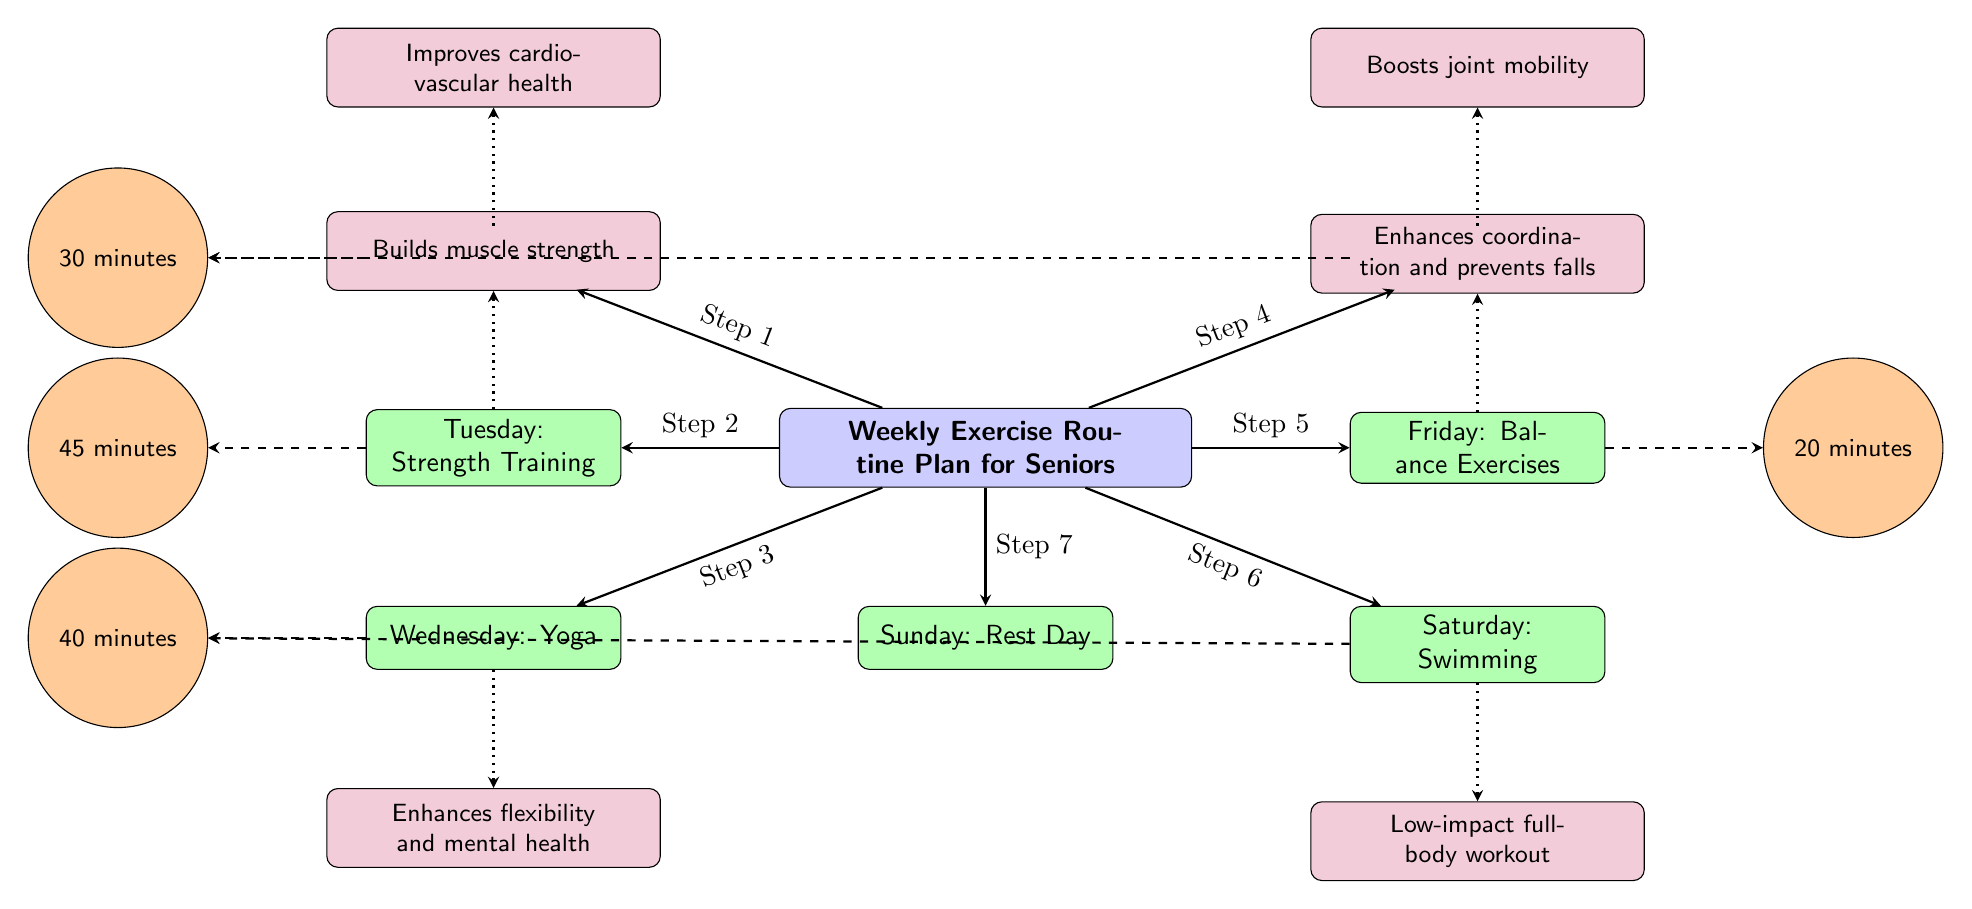What exercise is scheduled for Wednesday? The diagram shows that the exercise planned for Wednesday is "Yoga." This is directly represented in the "Wednesday" node.
Answer: Yoga How long should Tuesday's strength training last? According to the diagram, Tuesday's strength training is indicated to last for "45 minutes." This is found in the "duration" node connected to Tuesday.
Answer: 45 minutes What is the benefit of cycling on Thursday? The diagram states that the benefit of cycling on Thursday is "Boosts joint mobility." This information can be found in the respective "benefit" node connected to Thursday.
Answer: Boosts joint mobility Which exercise has the longest duration and what is that duration? The longest duration exercise is for “Strength Training” on Tuesday, which lasts "45 minutes." To confirm, one can compare the durations listed with each exercise and see that "45 minutes" is the highest.
Answer: 45 minutes What type of exercise is included for Saturday? The diagram specifies that the exercise planned for Saturday is "Swimming." This is visible in the "Saturday" node.
Answer: Swimming What is the health benefit associated with balance exercises? The diagram indicates that the health benefit of "Balance Exercises" on Friday is "Enhances coordination and prevents falls." This is connected explicitly in the benefit node for Friday.
Answer: Enhances coordination and prevents falls Which exercise corresponds to a 40-minute duration and on which day is it scheduled? The exercise scheduled for a 40-minute duration is "Yoga," which takes place on Wednesday. This was identified by checking the durations listed and their corresponding exercises.
Answer: Wednesday: Yoga How many exercises are scheduled for the week? The diagram outlines a total of 7 exercises throughout the week, as each day from Monday to Sunday represents a distinct exercise or rest day. This is verified by counting the days with assigned exercises.
Answer: 7 What exercise is assigned for the rest day? The diagram clearly establishes that Sunday is the "Rest Day," indicating that no exercise is scheduled for that day. This is found in the "Sunday" node.
Answer: Rest Day 